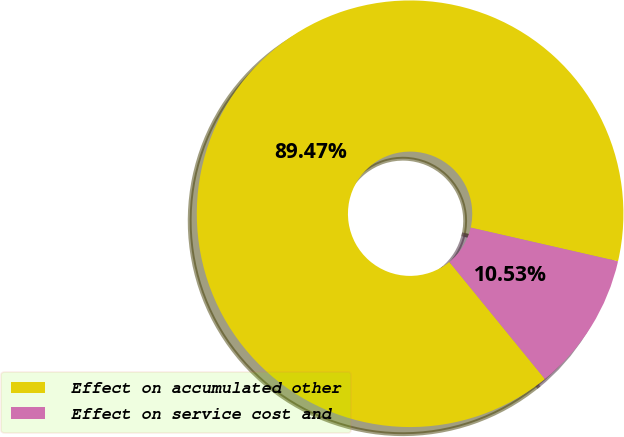Convert chart to OTSL. <chart><loc_0><loc_0><loc_500><loc_500><pie_chart><fcel>Effect on accumulated other<fcel>Effect on service cost and<nl><fcel>89.47%<fcel>10.53%<nl></chart> 